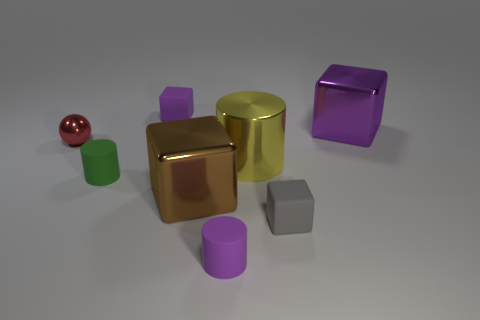The cylinder that is made of the same material as the big brown object is what size?
Ensure brevity in your answer.  Large. What is the size of the metallic block that is to the left of the yellow shiny thing?
Make the answer very short. Large. What number of purple blocks have the same size as the metallic cylinder?
Keep it short and to the point. 1. What is the color of the other rubber cylinder that is the same size as the green cylinder?
Provide a short and direct response. Purple. The large metal cylinder has what color?
Your answer should be very brief. Yellow. There is a thing that is to the right of the tiny gray cube; what is it made of?
Make the answer very short. Metal. What is the size of the purple rubber object that is the same shape as the yellow object?
Your response must be concise. Small. Are there fewer large yellow objects that are on the left side of the brown shiny cube than big brown shiny cubes?
Keep it short and to the point. Yes. Are any big cyan metallic spheres visible?
Offer a very short reply. No. What is the color of the other large thing that is the same shape as the green object?
Offer a very short reply. Yellow. 